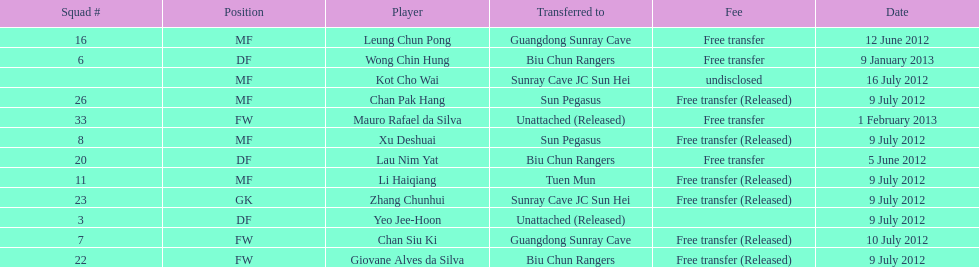Lau nim yat and giovane alves de silva where both transferred to which team? Biu Chun Rangers. 